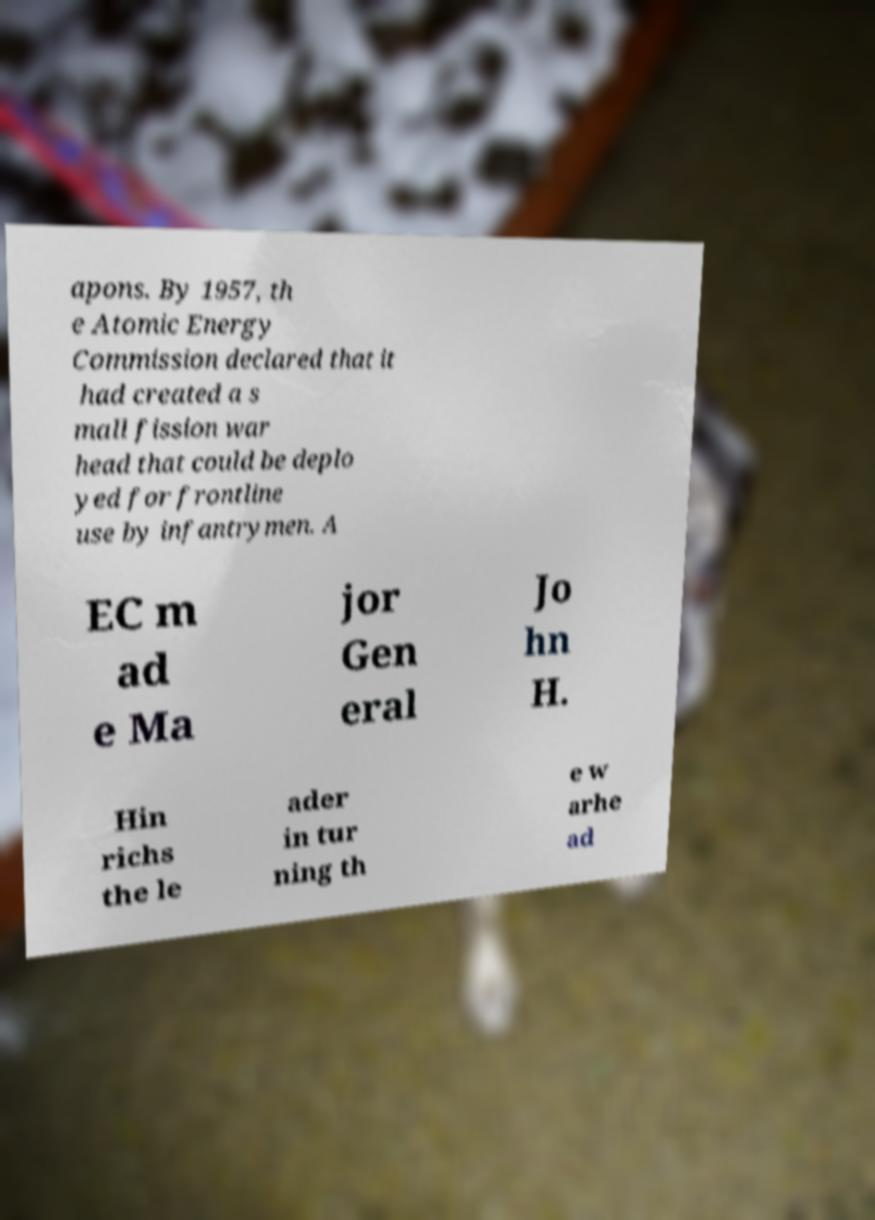There's text embedded in this image that I need extracted. Can you transcribe it verbatim? apons. By 1957, th e Atomic Energy Commission declared that it had created a s mall fission war head that could be deplo yed for frontline use by infantrymen. A EC m ad e Ma jor Gen eral Jo hn H. Hin richs the le ader in tur ning th e w arhe ad 